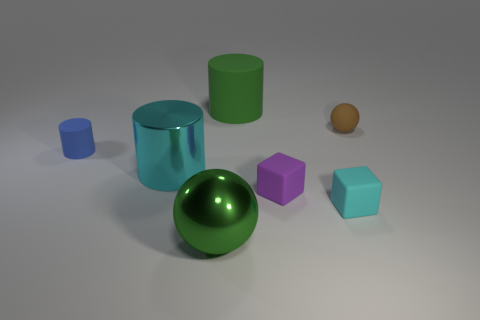Subtract all rubber cylinders. How many cylinders are left? 1 Add 1 large brown shiny cubes. How many objects exist? 8 Subtract 1 cylinders. How many cylinders are left? 2 Subtract all green balls. How many balls are left? 1 Subtract all balls. How many objects are left? 5 Subtract 0 brown cylinders. How many objects are left? 7 Subtract all brown cylinders. Subtract all purple blocks. How many cylinders are left? 3 Subtract all big cylinders. Subtract all cubes. How many objects are left? 3 Add 5 tiny purple blocks. How many tiny purple blocks are left? 6 Add 2 metallic cylinders. How many metallic cylinders exist? 3 